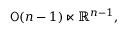Convert formula to latex. <formula><loc_0><loc_0><loc_500><loc_500>{ O } ( n - 1 ) \ltimes \mathbb { R } ^ { n - 1 } ,</formula> 